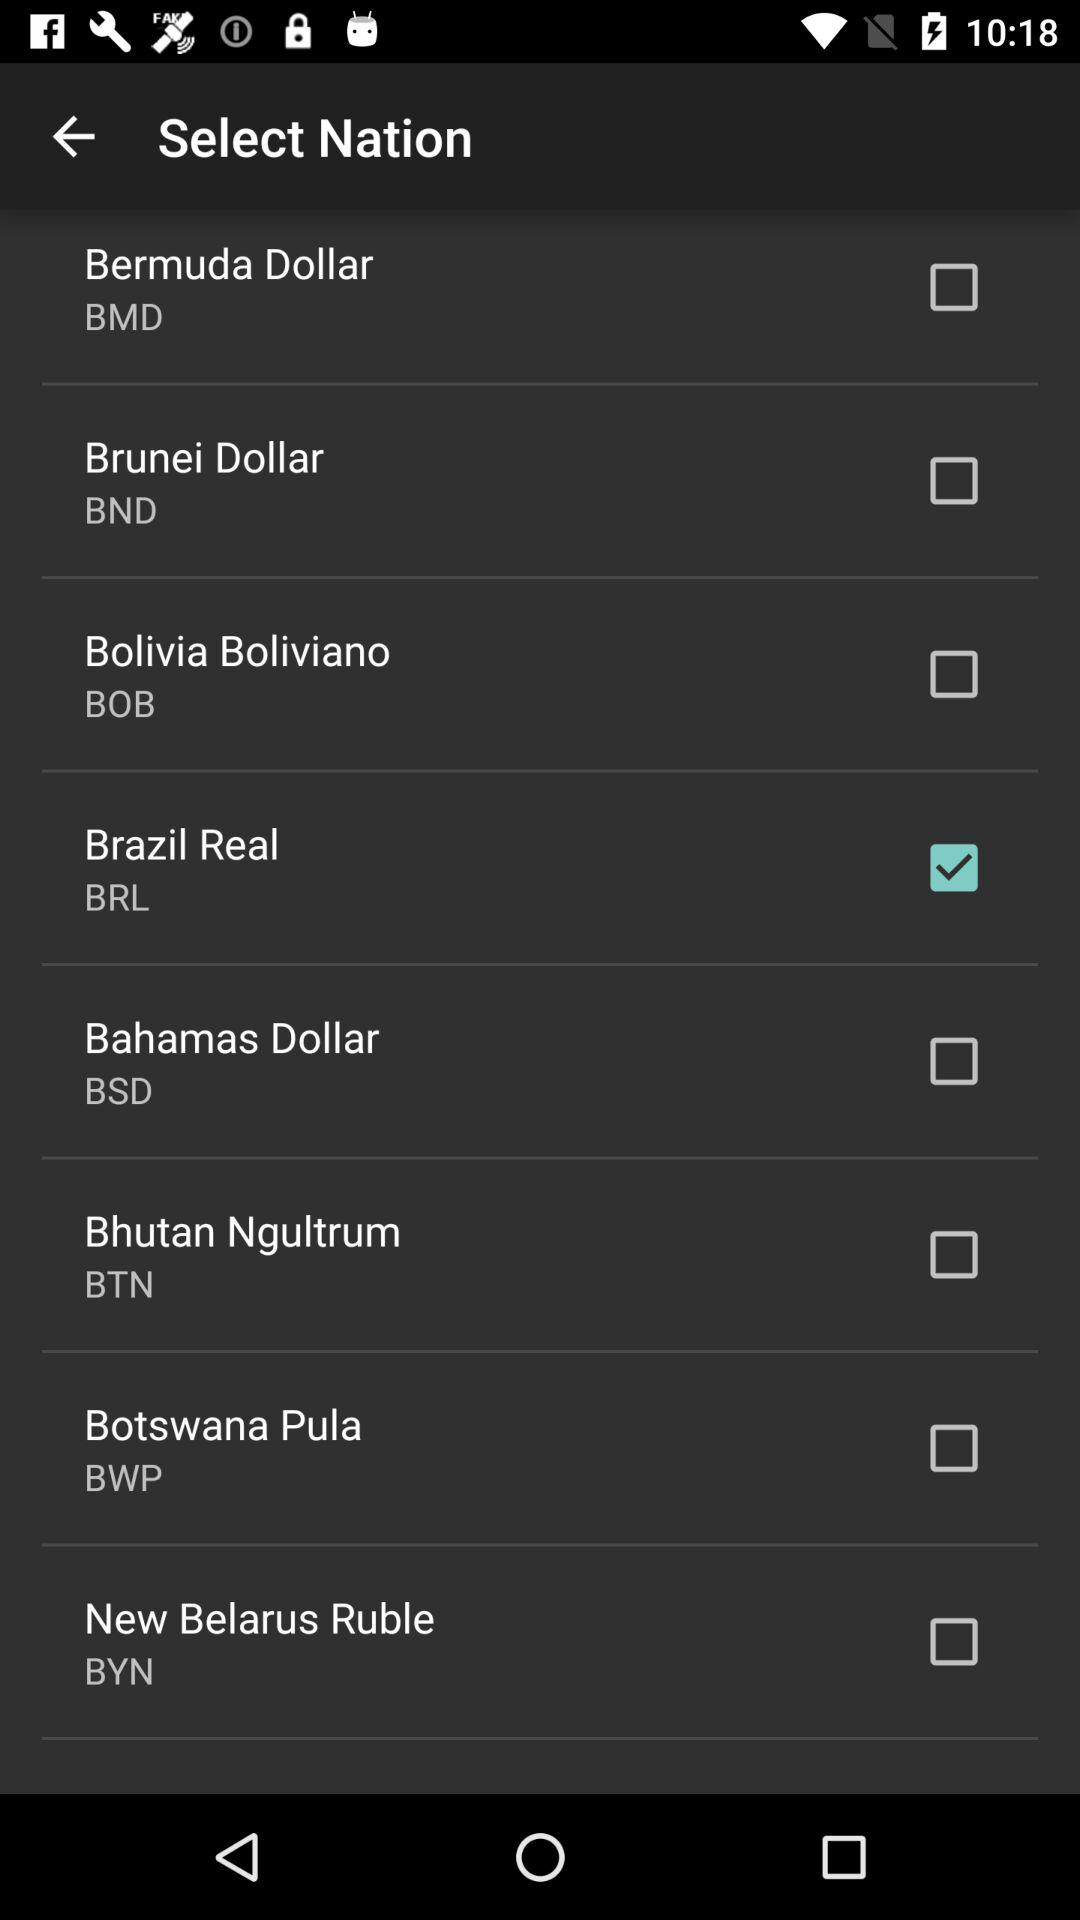Which currency is selected? The selected currency is the Brazilian real. 